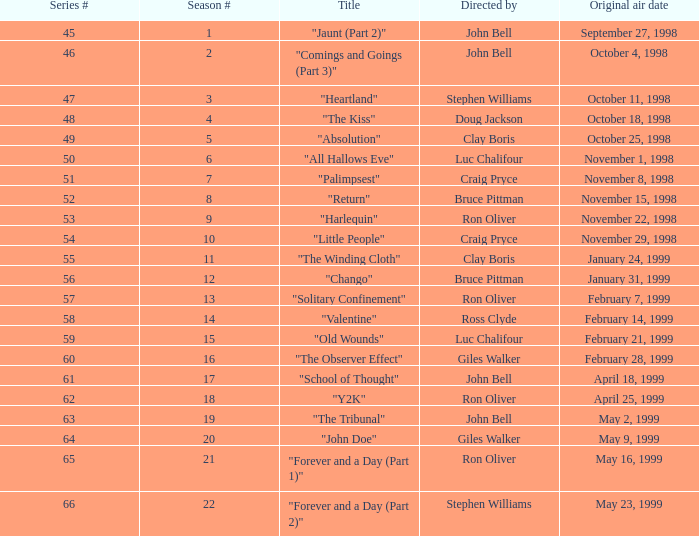Which Original air date has a Season # smaller than 21, and a Title of "palimpsest"? November 8, 1998. 